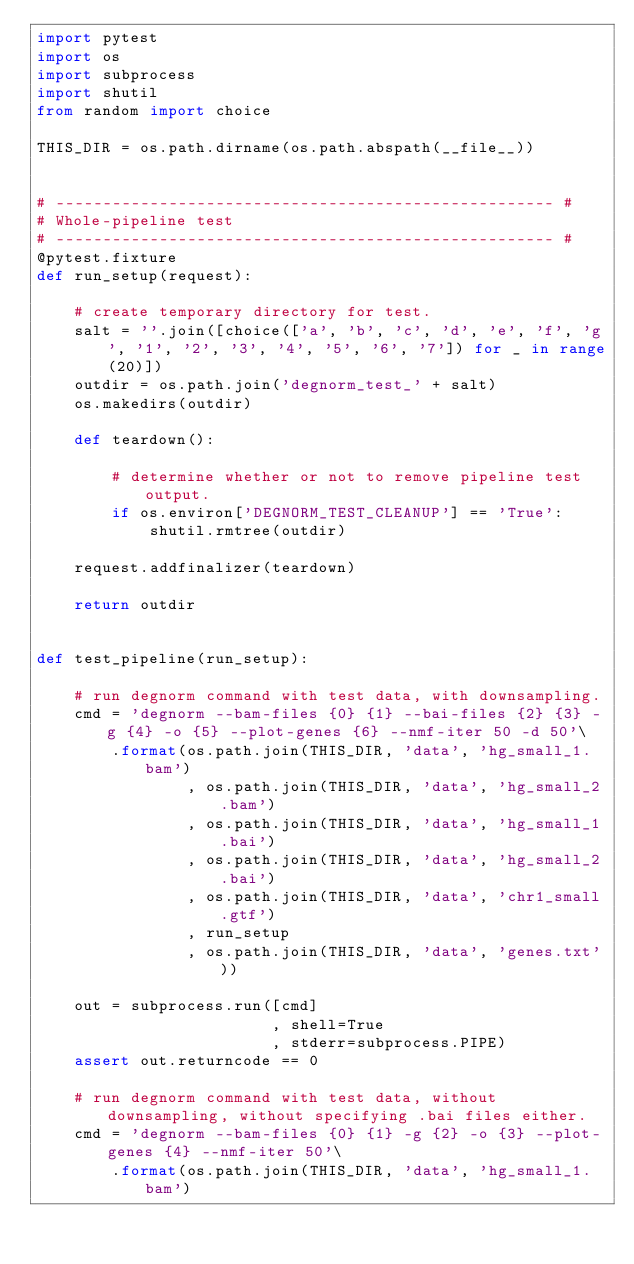<code> <loc_0><loc_0><loc_500><loc_500><_Python_>import pytest
import os
import subprocess
import shutil
from random import choice

THIS_DIR = os.path.dirname(os.path.abspath(__file__))


# ----------------------------------------------------- #
# Whole-pipeline test
# ----------------------------------------------------- #
@pytest.fixture
def run_setup(request):

    # create temporary directory for test.
    salt = ''.join([choice(['a', 'b', 'c', 'd', 'e', 'f', 'g', '1', '2', '3', '4', '5', '6', '7']) for _ in range(20)])
    outdir = os.path.join('degnorm_test_' + salt)
    os.makedirs(outdir)

    def teardown():

        # determine whether or not to remove pipeline test output.
        if os.environ['DEGNORM_TEST_CLEANUP'] == 'True':
            shutil.rmtree(outdir)

    request.addfinalizer(teardown)

    return outdir


def test_pipeline(run_setup):

    # run degnorm command with test data, with downsampling.
    cmd = 'degnorm --bam-files {0} {1} --bai-files {2} {3} -g {4} -o {5} --plot-genes {6} --nmf-iter 50 -d 50'\
        .format(os.path.join(THIS_DIR, 'data', 'hg_small_1.bam')
                , os.path.join(THIS_DIR, 'data', 'hg_small_2.bam')
                , os.path.join(THIS_DIR, 'data', 'hg_small_1.bai')
                , os.path.join(THIS_DIR, 'data', 'hg_small_2.bai')
                , os.path.join(THIS_DIR, 'data', 'chr1_small.gtf')
                , run_setup
                , os.path.join(THIS_DIR, 'data', 'genes.txt'))

    out = subprocess.run([cmd]
                         , shell=True
                         , stderr=subprocess.PIPE)
    assert out.returncode == 0

    # run degnorm command with test data, without downsampling, without specifying .bai files either.
    cmd = 'degnorm --bam-files {0} {1} -g {2} -o {3} --plot-genes {4} --nmf-iter 50'\
        .format(os.path.join(THIS_DIR, 'data', 'hg_small_1.bam')</code> 